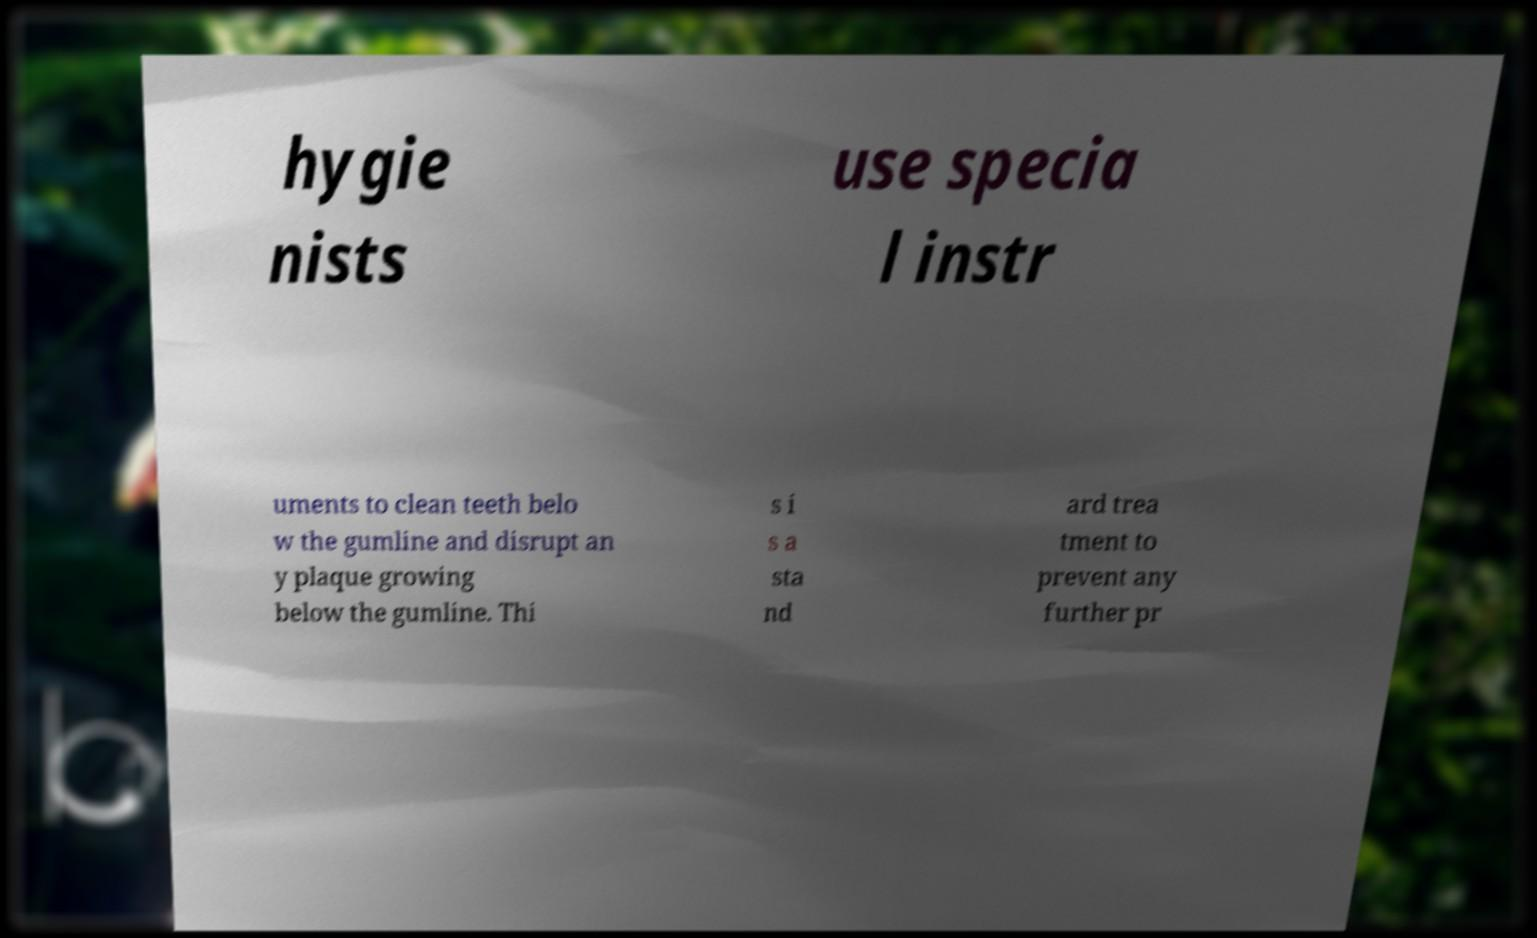Please read and relay the text visible in this image. What does it say? hygie nists use specia l instr uments to clean teeth belo w the gumline and disrupt an y plaque growing below the gumline. Thi s i s a sta nd ard trea tment to prevent any further pr 